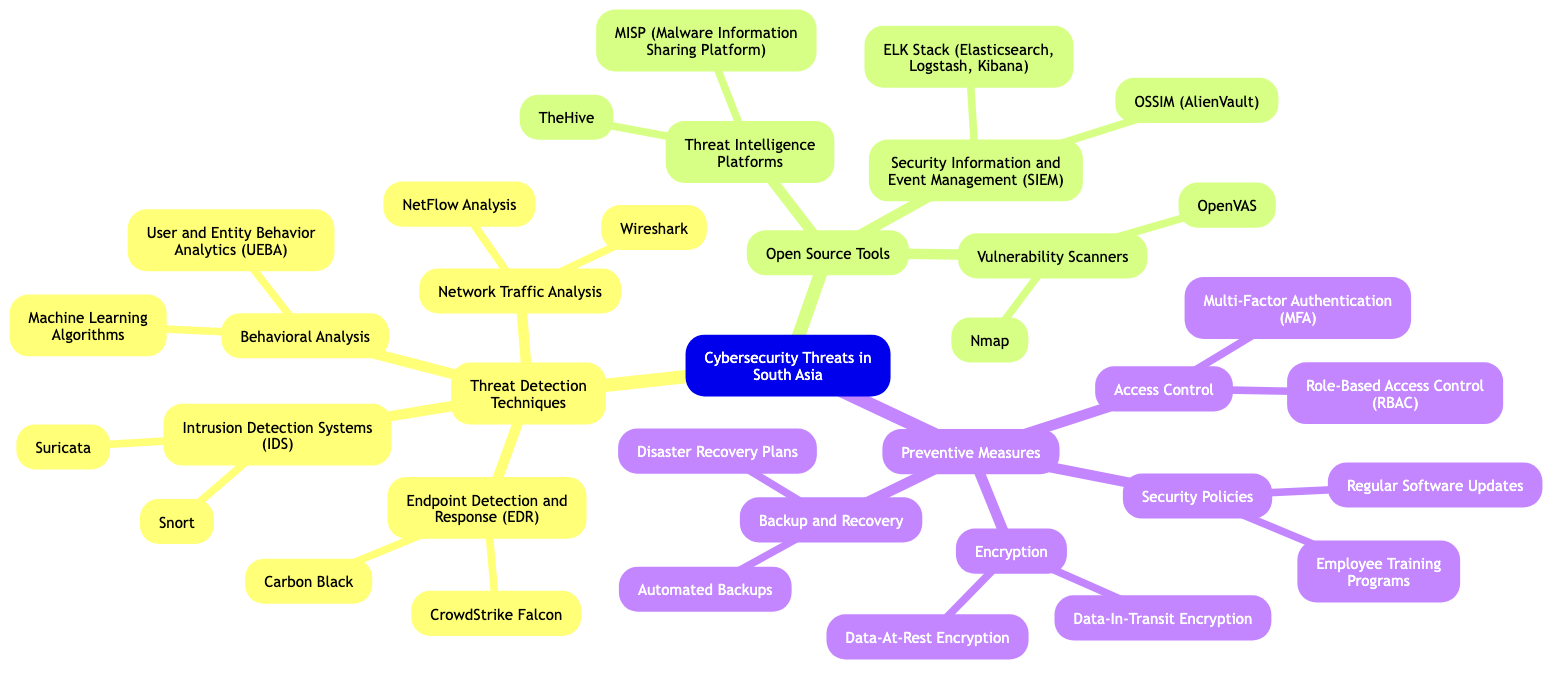What are the two main branches of the mind map? The central topic, "Cybersecurity Threats in South Asia," has three main branches: "Threat Detection Techniques," "Open Source Tools," and "Preventive Measures."
Answer: Threat Detection Techniques, Open Source Tools, Preventive Measures How many sub-branches are under "Open Source Tools"? Under the "Open Source Tools" branch, there are three sub-branches: "Threat Intelligence Platforms," "Vulnerability Scanners," and "Security Information and Event Management (SIEM)."
Answer: 3 What type of analysis is involved in the "Behavioral Analysis" branch? The "Behavioral Analysis" sub-branch includes "User and Entity Behavior Analytics (UEBA)" and "Machine Learning Algorithms," both of which focus on analyzing user behavior and predicting potential security threats.
Answer: User and Entity Behavior Analytics, Machine Learning Algorithms Which tool is listed under "Network Traffic Analysis"? "Wireshark" is a well-known tool listed under the "Network Traffic Analysis" sub-branch that helps in capturing and analyzing network packets.
Answer: Wireshark What is one preventive measure related to access control? The "Access Control" branch includes "Multi-Factor Authentication (MFA)" as one of the preventive measures to enhance security by requiring multiple forms of verification.
Answer: Multi-Factor Authentication What are the two types of encryption mentioned in the diagram? The "Encryption" branch contains two types: "Data-At-Rest Encryption" and "Data-In-Transit Encryption," both essential for protecting data during storage and transmission, respectively.
Answer: Data-At-Rest Encryption, Data-In-Transit Encryption Which tool is part of the Endpoint Detection and Response (EDR)? "CrowdStrike Falcon" is listed as one of the tools under the "Endpoint Detection and Response (EDR)" sub-branch, which is used for detecting and responding to threats on endpoints.
Answer: CrowdStrike Falcon Which vulnerability scanner is mentioned in the diagram? "OpenVAS" is a vulnerability scanner included in the "Vulnerability Scanners" sub-branch, often used for scanning networks for known vulnerabilities.
Answer: OpenVAS What is a key element of disaster recovery plans? The "Backup and Recovery" branch includes "Disaster Recovery Plans" as a key element to ensure data and system recovery after incidents.
Answer: Disaster Recovery Plans 